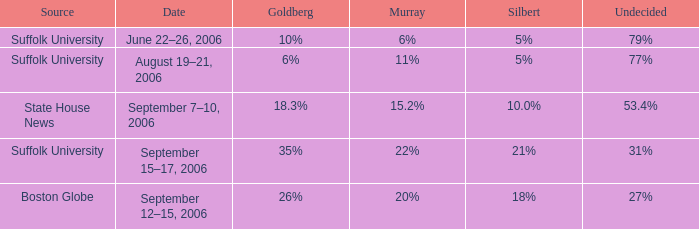What is the undecided percentage of the poll where Goldberg had 6%? 77%. 